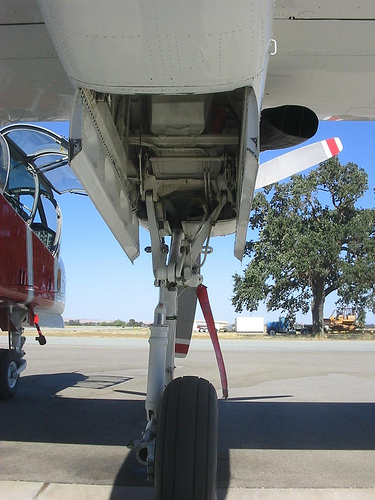<image>
Can you confirm if the airplane is on the ground? Yes. Looking at the image, I can see the airplane is positioned on top of the ground, with the ground providing support. 